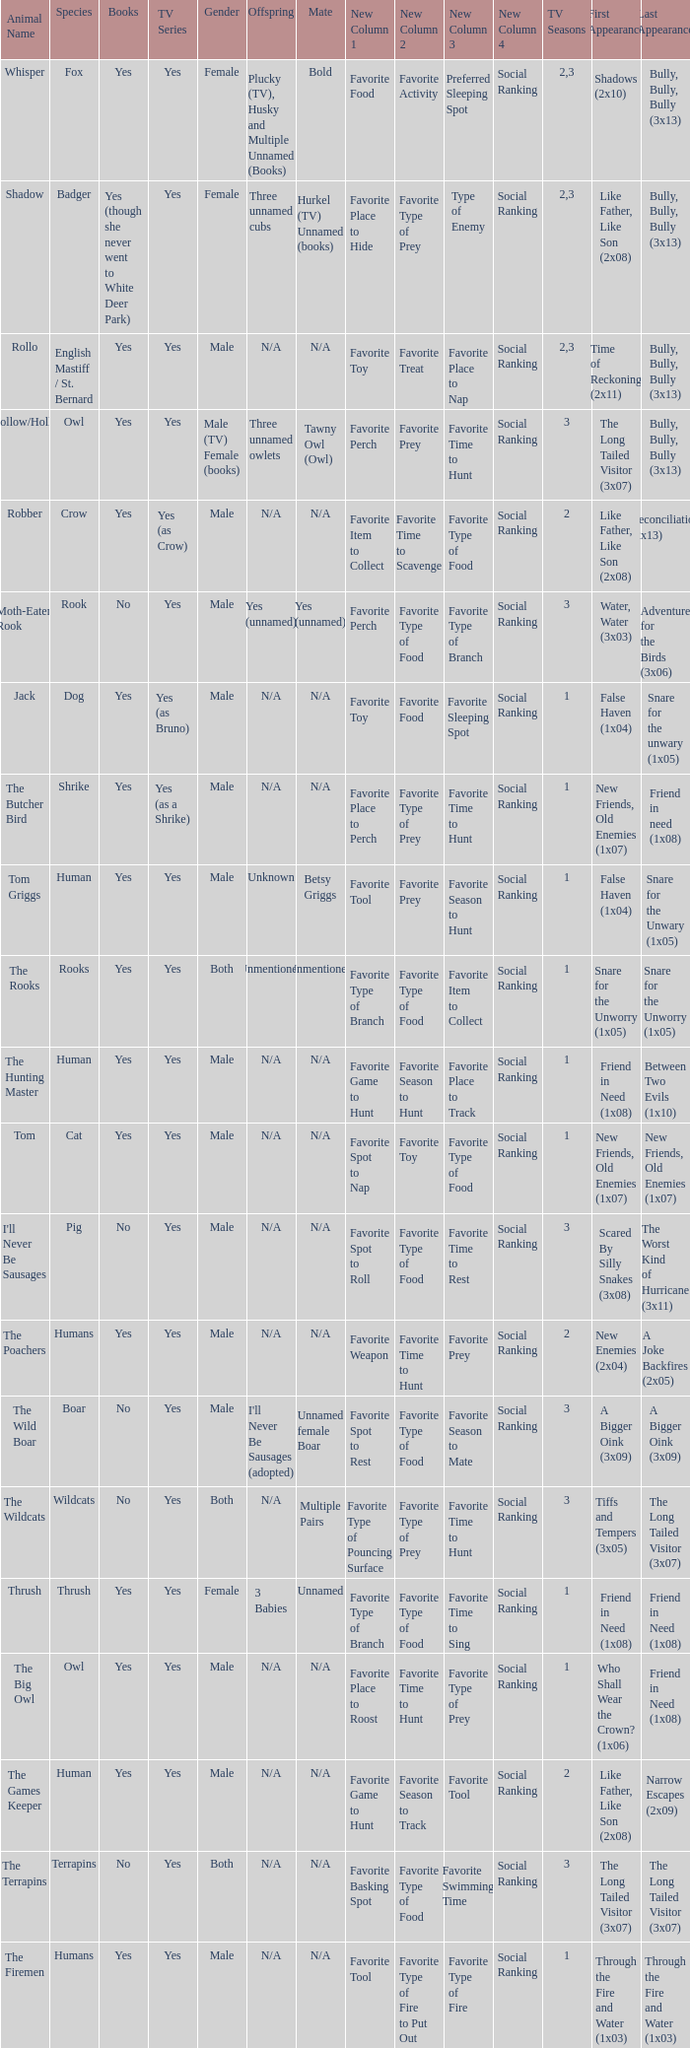What is the smallest season for a tv series with a yes and human was the species? 1.0. 